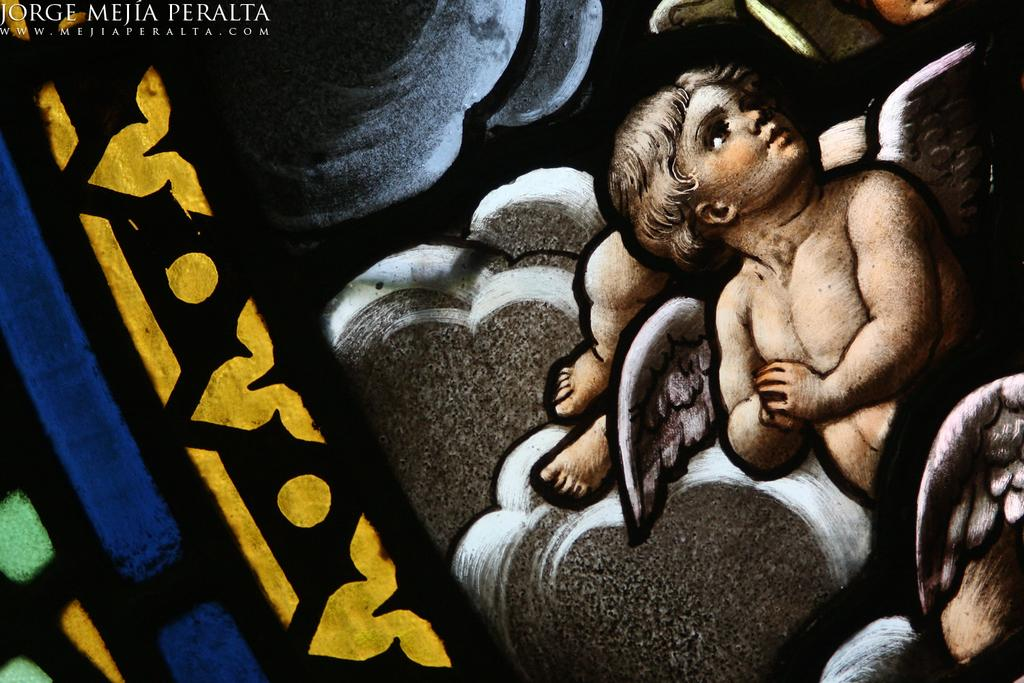What is depicted in the image? There is a painting in the image. Can you describe the subject of the painting? There is a man in the painting. What is the man doing in the painting? The man is holding his hands in the painting. Are there any unique features about the man in the painting? Yes, the man has wings in the painting. How many dolls are present in the painting? There are no dolls present in the painting; it features a man with wings. What is the man's tongue doing in the painting? There is no mention of the man's tongue in the painting; he is holding his hands. 